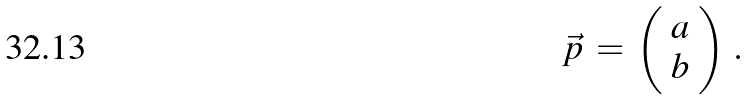Convert formula to latex. <formula><loc_0><loc_0><loc_500><loc_500>\vec { p } \, = \, \left ( \begin{array} { c c } { a } \\ { b } \end{array} \right ) \, .</formula> 